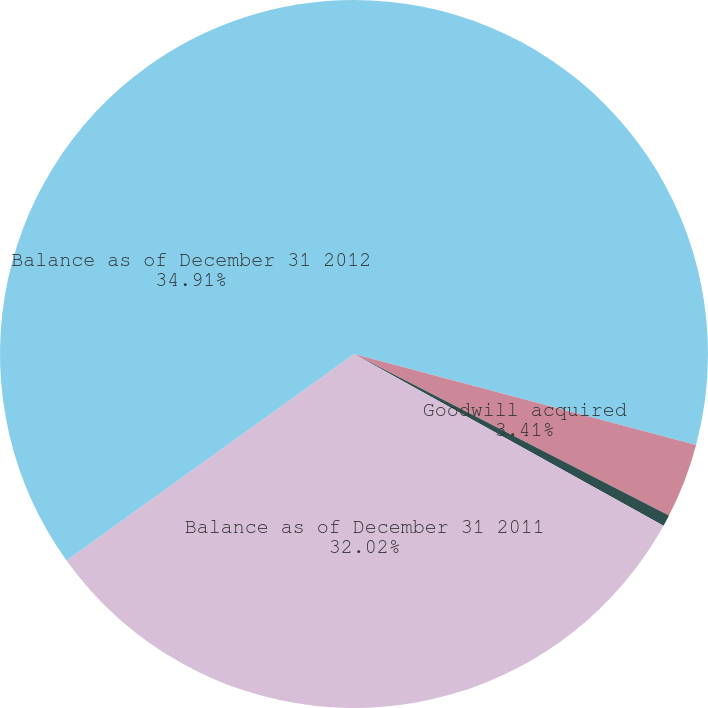Convert chart to OTSL. <chart><loc_0><loc_0><loc_500><loc_500><pie_chart><fcel>Balance as of January 1 2011<fcel>Goodwill acquired<fcel>Foreign currency translation<fcel>Balance as of December 31 2011<fcel>Balance as of December 31 2012<nl><fcel>29.14%<fcel>3.41%<fcel>0.52%<fcel>32.03%<fcel>34.92%<nl></chart> 